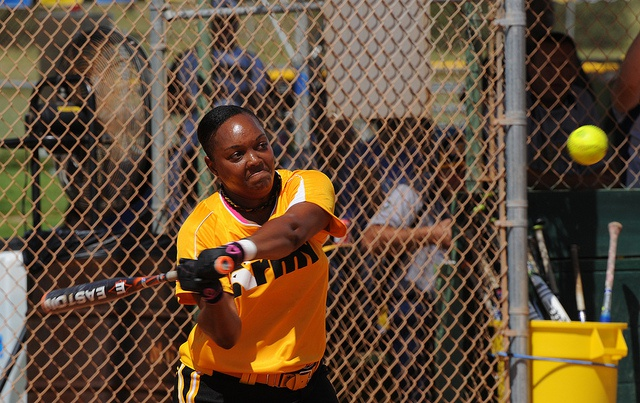Describe the objects in this image and their specific colors. I can see people in blue, black, brown, maroon, and orange tones, baseball bat in blue, maroon, black, gray, and darkgray tones, people in blue, black, maroon, and gray tones, sports ball in blue, yellow, and olive tones, and baseball bat in blue, darkgray, and gray tones in this image. 